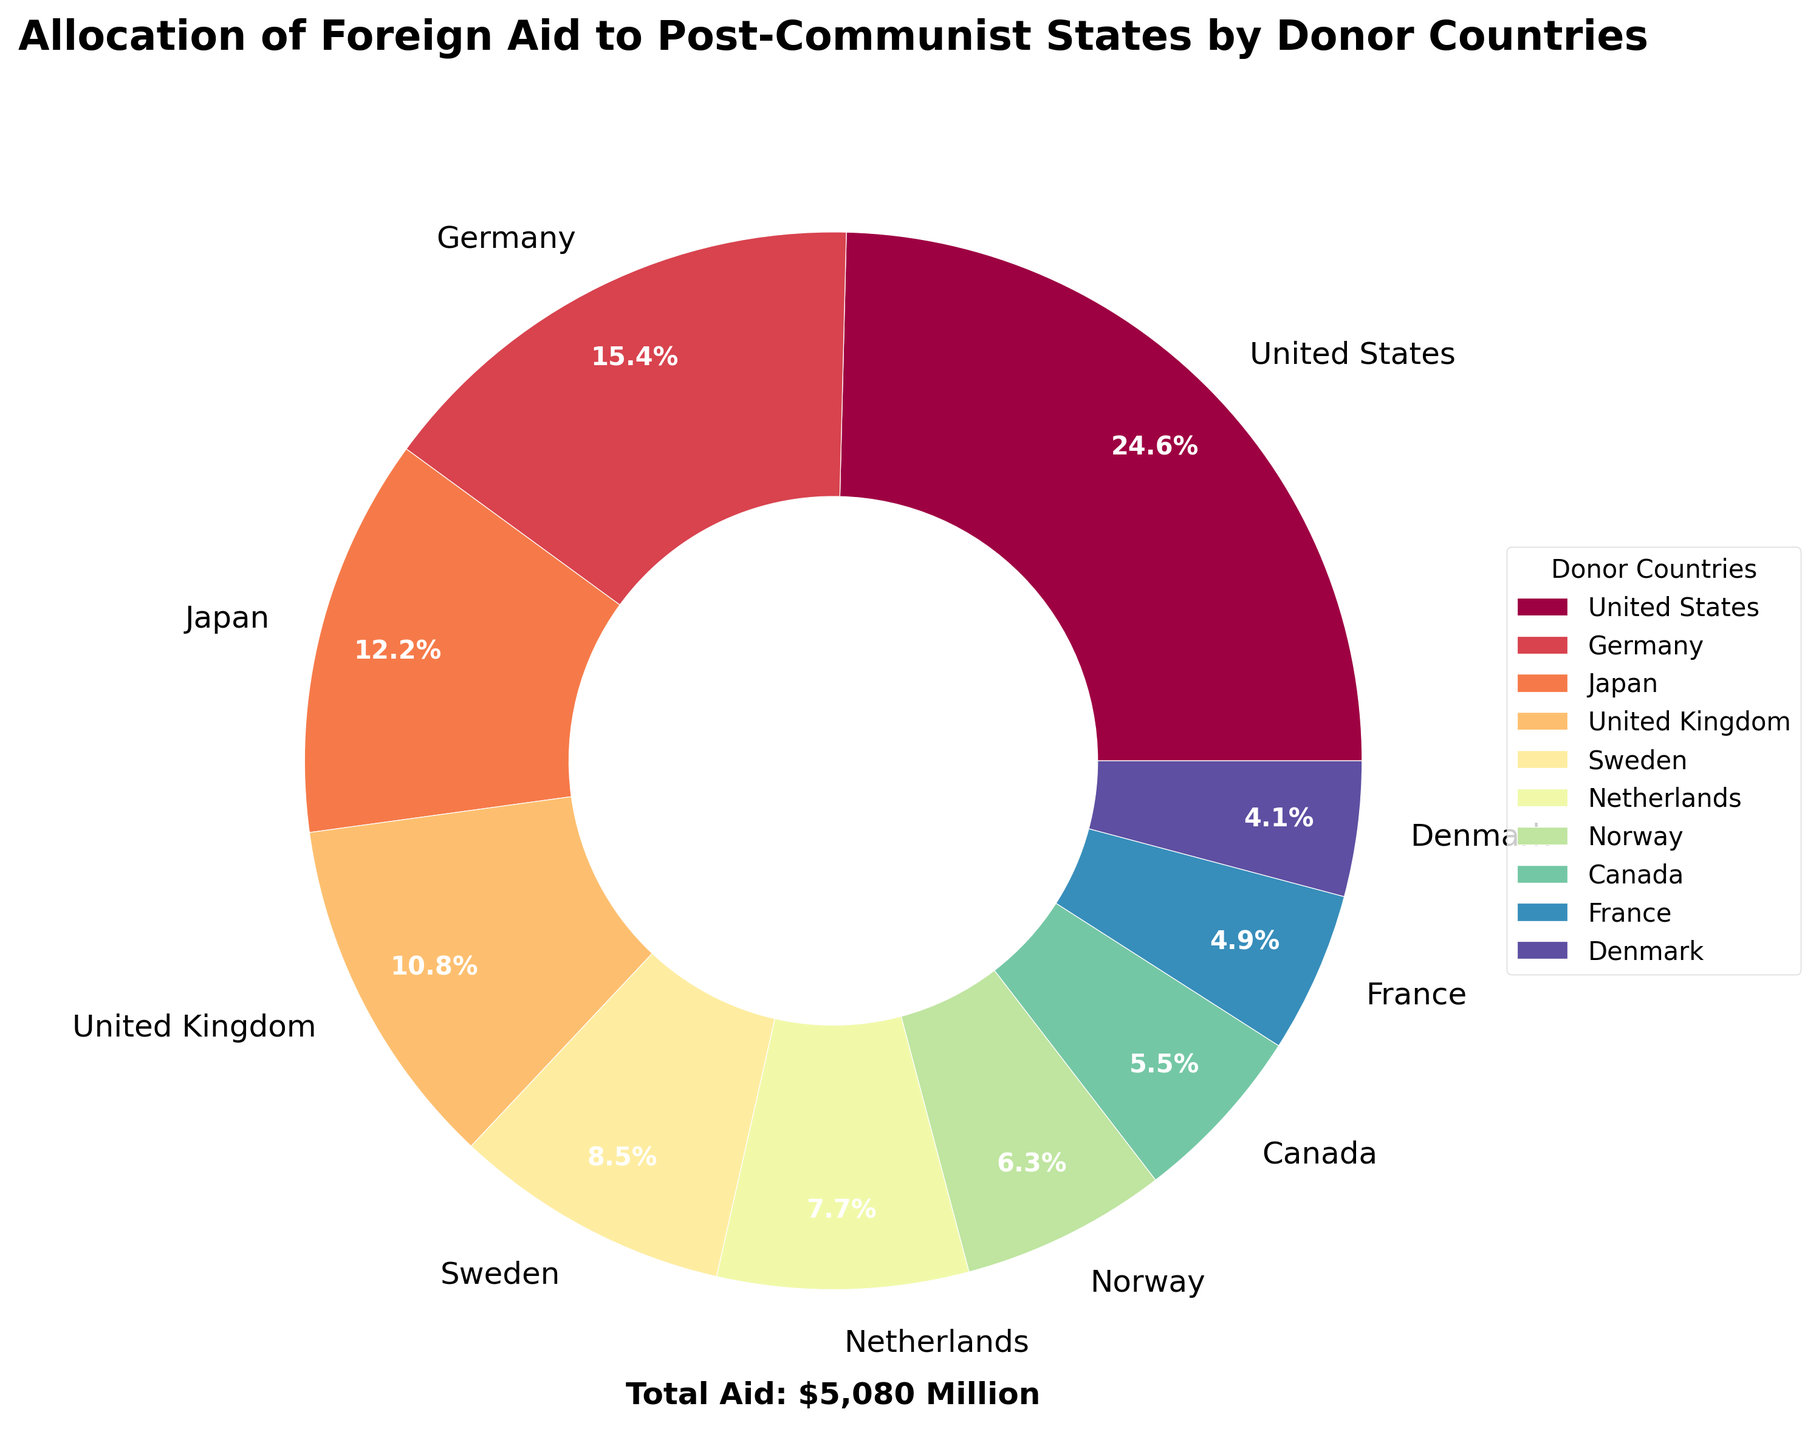Which country provides the largest amount of foreign aid? The figure shows a pie chart with different segments labeled with the donor countries. The largest segment corresponds to the United States.
Answer: United States What percentage of total foreign aid is provided by Japan? Each segment in the pie chart represents a percentage of the total aid. The segment labeled as Japan shows a percentage of 17.2%.
Answer: 17.2% How much more aid does Germany provide compared to Canada? Identify the aid amounts for Germany and Canada. Germany provides 780 million USD and Canada provides 280 million USD. The difference is 780 - 280 = 500 million USD.
Answer: 500 million USD Which country provides the smallest amount of foreign aid? The smallest segment in the pie chart is labeled with Denmark, indicating it provides the smallest amount of aid.
Answer: Denmark What is the combined contribution of the United Kingdom and Sweden? From the pie chart, the United Kingdom provides 550 million USD and Sweden provides 430 million USD. Adding these gives 550 + 430 = 980 million USD.
Answer: 980 million USD What is the visual relationship between the segments for Norway and the Netherlands? Find the segments. The segment for Norway is slightly smaller than that for the Netherlands, indicating Norway provides less aid than the Netherlands.
Answer: Norway provides less aid Compare the total contributions of the top three donor countries to the total contributions of the remaining donor countries. Top three donor countries are the United States (1250 million USD), Germany (780 million USD), and Japan (620 million USD). Their total is 1250 + 780 + 620 = 2650 million USD. The other countries contribute 550 + 430 + 390 + 320 + 280 + 250 + 210 = 2430 million USD.
Answer: Top three donors contribute more How much aid would need to be added to France's contribution to equal the contribution of the United Kingdom? France's contribution is 250 million USD and the United Kingdom's is 550 million USD. The difference is 550 - 250 = 300 million USD.
Answer: 300 million USD What percentage of total aid is provided by the Scandinavian countries (Sweden, Denmark, Norway)? The segments for Sweden, Denmark, and Norway show 11.9%, 5.8%, and 8.9%, respectively. Summing these gives 11.9 + 5.8 + 8.9 = 26.6%.
Answer: 26.6% 